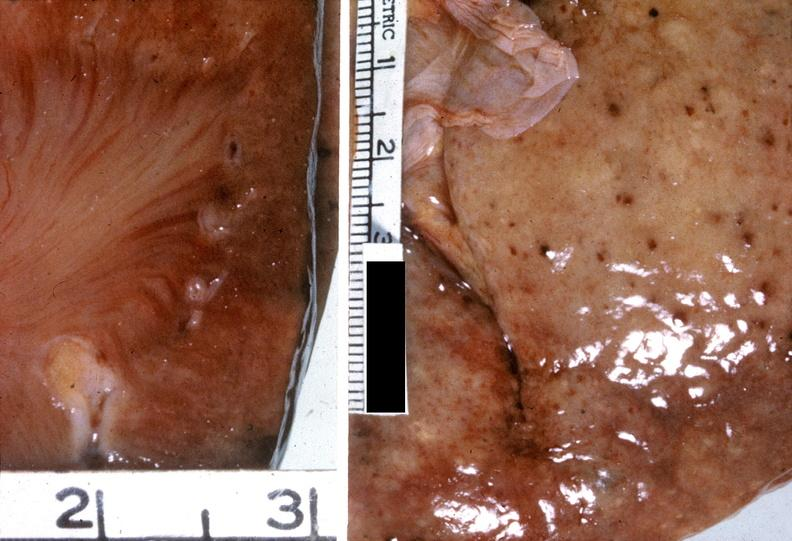where is this?
Answer the question using a single word or phrase. Urinary 